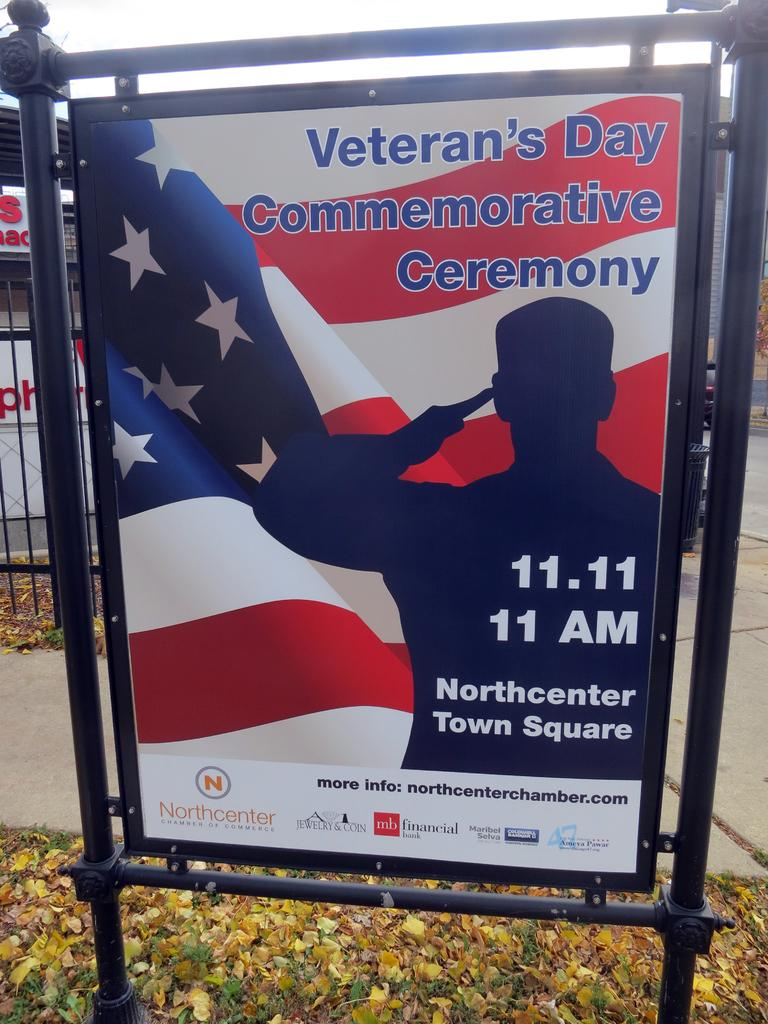What is the main object in the image? There is a board in the image. What can be seen on the ground in the image? There are leaves on a path in the image. How many yaks are visible in the image? There are no yaks present in the image. What color are the eyes of the laborer in the image? There is no laborer present in the image. 